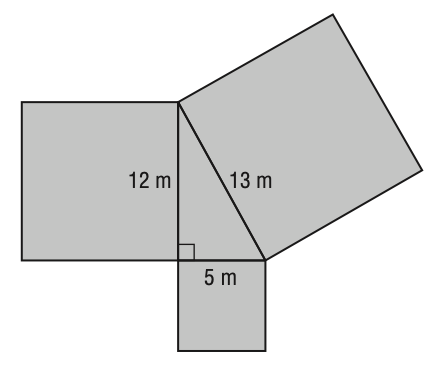Question: What is the total area of the figure?
Choices:
A. 30
B. 184
C. 338
D. 368
Answer with the letter. Answer: D 